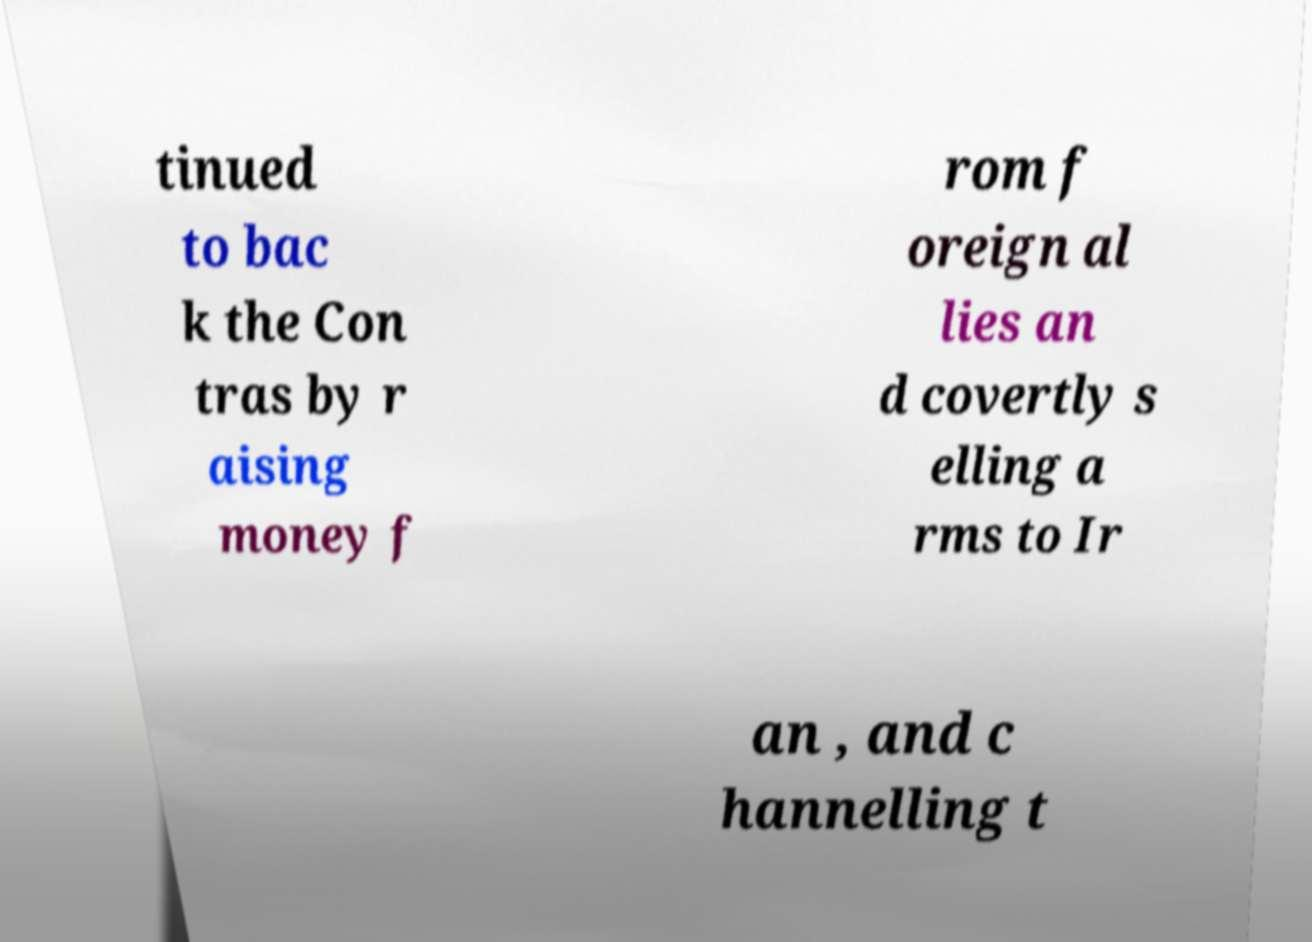I need the written content from this picture converted into text. Can you do that? tinued to bac k the Con tras by r aising money f rom f oreign al lies an d covertly s elling a rms to Ir an , and c hannelling t 